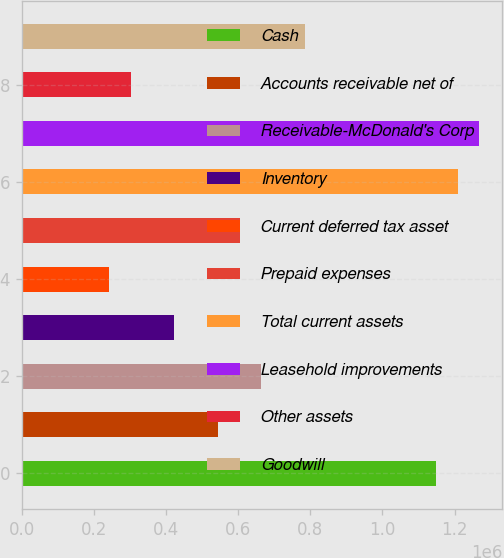Convert chart to OTSL. <chart><loc_0><loc_0><loc_500><loc_500><bar_chart><fcel>Cash<fcel>Accounts receivable net of<fcel>Receivable-McDonald's Corp<fcel>Inventory<fcel>Current deferred tax asset<fcel>Prepaid expenses<fcel>Total current assets<fcel>Leasehold improvements<fcel>Other assets<fcel>Goodwill<nl><fcel>1.14799e+06<fcel>543788<fcel>664628<fcel>422948<fcel>241687<fcel>604208<fcel>1.20841e+06<fcel>1.26883e+06<fcel>302108<fcel>785468<nl></chart> 